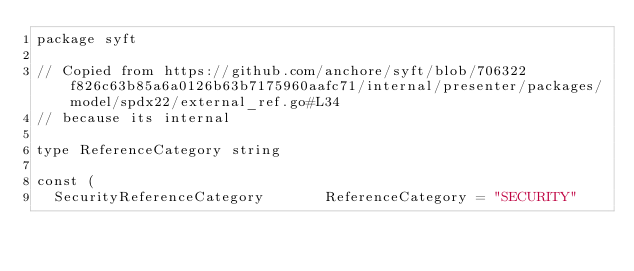Convert code to text. <code><loc_0><loc_0><loc_500><loc_500><_Go_>package syft

// Copied from https://github.com/anchore/syft/blob/706322f826c63b85a6a0126b63b7175960aafc71/internal/presenter/packages/model/spdx22/external_ref.go#L34
// because its internal

type ReferenceCategory string

const (
	SecurityReferenceCategory       ReferenceCategory = "SECURITY"</code> 